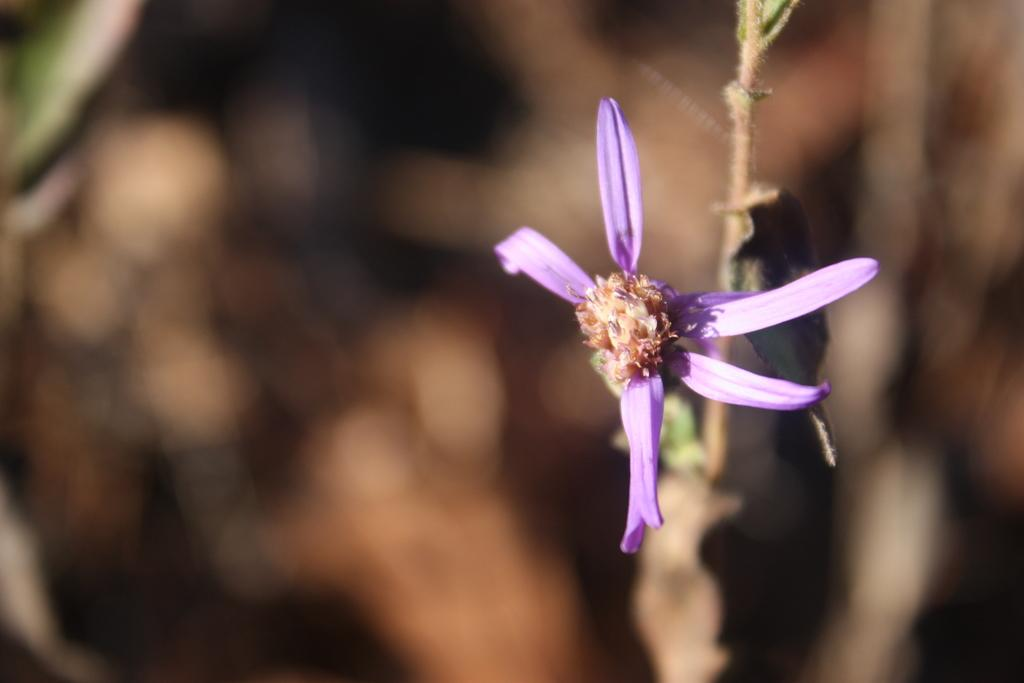What is the main subject of the image? There is a flower in the image. What color is the flower? The flower is violet in color. Can you describe the background of the image? The background of the image is blurred. What type of government is depicted in the image? There is no government depicted in the image; it features a violet flower with a blurred background. How many kittens are playing with the flower in the image? There are no kittens present in the image; it only features a violet flower with a blurred background. 